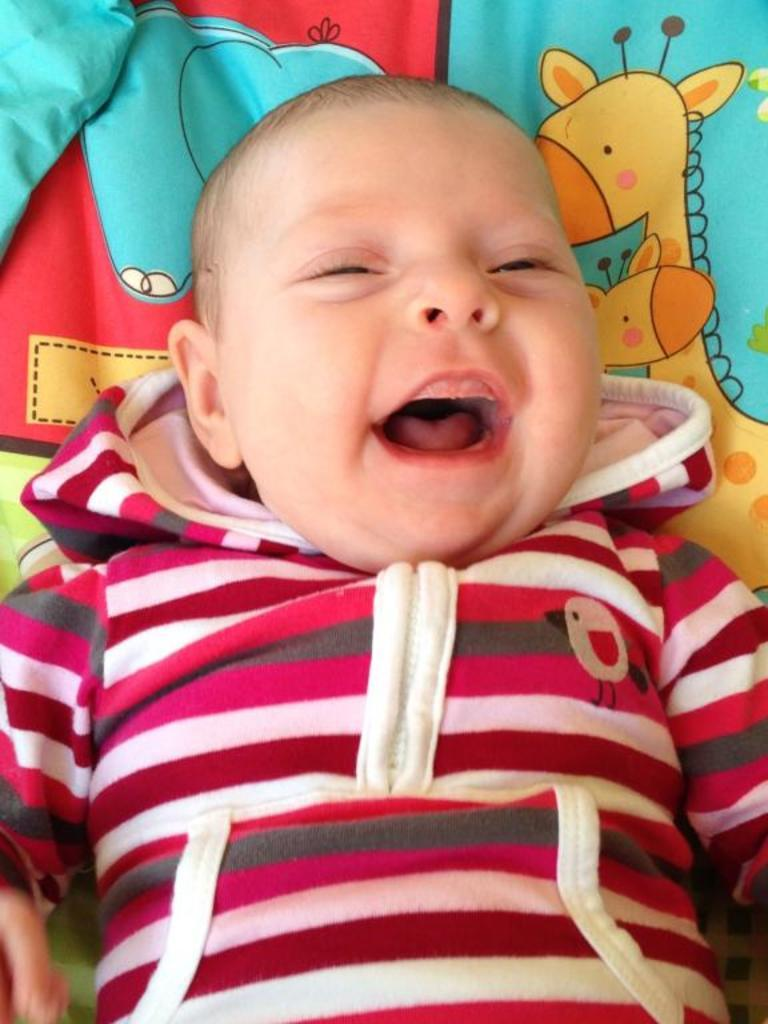What is the main subject of the image? There is a baby in the image. What is the baby doing in the image? The baby is lying down and smiling. What is present in the image to provide comfort or support for the baby? There is a pillow in the image. What type of trees can be seen in the background of the image? There are no trees visible in the image; it features a baby lying down on a pillow. What is the zinc content of the baby's food in the image? There is no information about the baby's food in the image, so it is impossible to determine the zinc content. 